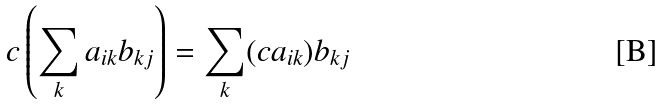<formula> <loc_0><loc_0><loc_500><loc_500>c \left ( \sum _ { k } a _ { i k } b _ { k j } \right ) = \sum _ { k } ( c a _ { i k } ) b _ { k j }</formula> 